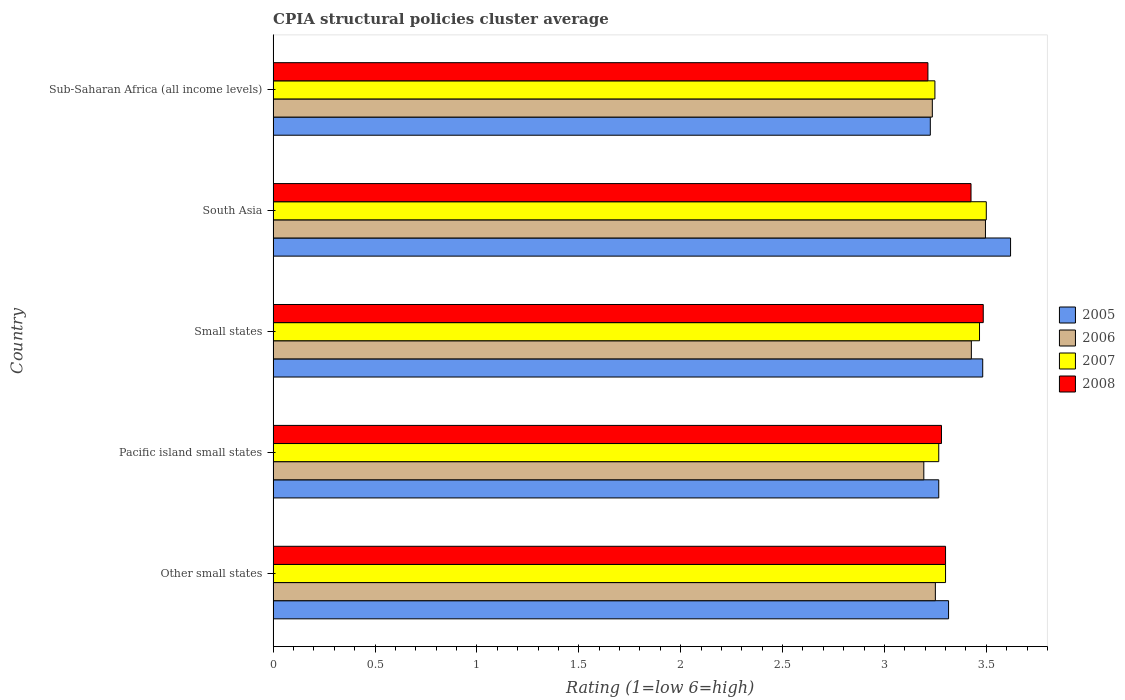Are the number of bars per tick equal to the number of legend labels?
Offer a very short reply. Yes. How many bars are there on the 5th tick from the bottom?
Your response must be concise. 4. What is the label of the 3rd group of bars from the top?
Provide a short and direct response. Small states. What is the CPIA rating in 2008 in Pacific island small states?
Offer a very short reply. 3.28. Across all countries, what is the maximum CPIA rating in 2008?
Provide a succinct answer. 3.48. Across all countries, what is the minimum CPIA rating in 2007?
Your answer should be very brief. 3.25. In which country was the CPIA rating in 2008 maximum?
Your answer should be compact. Small states. In which country was the CPIA rating in 2006 minimum?
Keep it short and to the point. Pacific island small states. What is the total CPIA rating in 2006 in the graph?
Provide a short and direct response. 16.6. What is the difference between the CPIA rating in 2005 in Other small states and that in Pacific island small states?
Make the answer very short. 0.05. What is the difference between the CPIA rating in 2007 in Pacific island small states and the CPIA rating in 2006 in Other small states?
Your answer should be very brief. 0.02. What is the average CPIA rating in 2008 per country?
Your answer should be compact. 3.34. What is the difference between the CPIA rating in 2007 and CPIA rating in 2006 in Sub-Saharan Africa (all income levels)?
Your answer should be compact. 0.01. In how many countries, is the CPIA rating in 2007 greater than 1.5 ?
Provide a short and direct response. 5. What is the ratio of the CPIA rating in 2005 in Pacific island small states to that in Sub-Saharan Africa (all income levels)?
Ensure brevity in your answer.  1.01. Is the difference between the CPIA rating in 2007 in Small states and South Asia greater than the difference between the CPIA rating in 2006 in Small states and South Asia?
Your response must be concise. Yes. What is the difference between the highest and the second highest CPIA rating in 2006?
Provide a succinct answer. 0.07. What is the difference between the highest and the lowest CPIA rating in 2006?
Provide a succinct answer. 0.3. In how many countries, is the CPIA rating in 2005 greater than the average CPIA rating in 2005 taken over all countries?
Provide a short and direct response. 2. Is the sum of the CPIA rating in 2008 in Other small states and Small states greater than the maximum CPIA rating in 2007 across all countries?
Provide a short and direct response. Yes. Is it the case that in every country, the sum of the CPIA rating in 2008 and CPIA rating in 2007 is greater than the CPIA rating in 2006?
Offer a terse response. Yes. How many countries are there in the graph?
Keep it short and to the point. 5. What is the difference between two consecutive major ticks on the X-axis?
Keep it short and to the point. 0.5. Does the graph contain grids?
Your response must be concise. No. How are the legend labels stacked?
Offer a terse response. Vertical. What is the title of the graph?
Your answer should be compact. CPIA structural policies cluster average. What is the label or title of the Y-axis?
Your answer should be very brief. Country. What is the Rating (1=low 6=high) of 2005 in Other small states?
Your response must be concise. 3.31. What is the Rating (1=low 6=high) in 2006 in Other small states?
Offer a very short reply. 3.25. What is the Rating (1=low 6=high) in 2008 in Other small states?
Keep it short and to the point. 3.3. What is the Rating (1=low 6=high) of 2005 in Pacific island small states?
Your response must be concise. 3.27. What is the Rating (1=low 6=high) of 2006 in Pacific island small states?
Make the answer very short. 3.19. What is the Rating (1=low 6=high) of 2007 in Pacific island small states?
Make the answer very short. 3.27. What is the Rating (1=low 6=high) in 2008 in Pacific island small states?
Keep it short and to the point. 3.28. What is the Rating (1=low 6=high) of 2005 in Small states?
Provide a succinct answer. 3.48. What is the Rating (1=low 6=high) of 2006 in Small states?
Your answer should be very brief. 3.43. What is the Rating (1=low 6=high) of 2007 in Small states?
Provide a succinct answer. 3.47. What is the Rating (1=low 6=high) of 2008 in Small states?
Your answer should be compact. 3.48. What is the Rating (1=low 6=high) of 2005 in South Asia?
Provide a short and direct response. 3.62. What is the Rating (1=low 6=high) in 2006 in South Asia?
Your response must be concise. 3.5. What is the Rating (1=low 6=high) of 2008 in South Asia?
Make the answer very short. 3.42. What is the Rating (1=low 6=high) in 2005 in Sub-Saharan Africa (all income levels)?
Your answer should be very brief. 3.23. What is the Rating (1=low 6=high) of 2006 in Sub-Saharan Africa (all income levels)?
Make the answer very short. 3.24. What is the Rating (1=low 6=high) in 2007 in Sub-Saharan Africa (all income levels)?
Your response must be concise. 3.25. What is the Rating (1=low 6=high) of 2008 in Sub-Saharan Africa (all income levels)?
Offer a terse response. 3.21. Across all countries, what is the maximum Rating (1=low 6=high) of 2005?
Your answer should be very brief. 3.62. Across all countries, what is the maximum Rating (1=low 6=high) in 2006?
Provide a succinct answer. 3.5. Across all countries, what is the maximum Rating (1=low 6=high) in 2008?
Give a very brief answer. 3.48. Across all countries, what is the minimum Rating (1=low 6=high) in 2005?
Provide a succinct answer. 3.23. Across all countries, what is the minimum Rating (1=low 6=high) in 2006?
Keep it short and to the point. 3.19. Across all countries, what is the minimum Rating (1=low 6=high) in 2007?
Provide a short and direct response. 3.25. Across all countries, what is the minimum Rating (1=low 6=high) in 2008?
Make the answer very short. 3.21. What is the total Rating (1=low 6=high) in 2005 in the graph?
Provide a short and direct response. 16.91. What is the total Rating (1=low 6=high) of 2006 in the graph?
Provide a succinct answer. 16.6. What is the total Rating (1=low 6=high) of 2007 in the graph?
Provide a succinct answer. 16.78. What is the total Rating (1=low 6=high) in 2008 in the graph?
Your response must be concise. 16.7. What is the difference between the Rating (1=low 6=high) in 2005 in Other small states and that in Pacific island small states?
Provide a short and direct response. 0.05. What is the difference between the Rating (1=low 6=high) in 2006 in Other small states and that in Pacific island small states?
Provide a short and direct response. 0.06. What is the difference between the Rating (1=low 6=high) in 2008 in Other small states and that in Pacific island small states?
Offer a terse response. 0.02. What is the difference between the Rating (1=low 6=high) of 2005 in Other small states and that in Small states?
Provide a short and direct response. -0.17. What is the difference between the Rating (1=low 6=high) in 2006 in Other small states and that in Small states?
Offer a very short reply. -0.18. What is the difference between the Rating (1=low 6=high) of 2008 in Other small states and that in Small states?
Provide a succinct answer. -0.18. What is the difference between the Rating (1=low 6=high) of 2005 in Other small states and that in South Asia?
Your answer should be very brief. -0.3. What is the difference between the Rating (1=low 6=high) in 2006 in Other small states and that in South Asia?
Your response must be concise. -0.25. What is the difference between the Rating (1=low 6=high) in 2008 in Other small states and that in South Asia?
Ensure brevity in your answer.  -0.12. What is the difference between the Rating (1=low 6=high) of 2005 in Other small states and that in Sub-Saharan Africa (all income levels)?
Your answer should be very brief. 0.09. What is the difference between the Rating (1=low 6=high) in 2006 in Other small states and that in Sub-Saharan Africa (all income levels)?
Provide a short and direct response. 0.01. What is the difference between the Rating (1=low 6=high) in 2007 in Other small states and that in Sub-Saharan Africa (all income levels)?
Your answer should be compact. 0.05. What is the difference between the Rating (1=low 6=high) in 2008 in Other small states and that in Sub-Saharan Africa (all income levels)?
Your answer should be very brief. 0.09. What is the difference between the Rating (1=low 6=high) in 2005 in Pacific island small states and that in Small states?
Offer a terse response. -0.22. What is the difference between the Rating (1=low 6=high) in 2006 in Pacific island small states and that in Small states?
Make the answer very short. -0.23. What is the difference between the Rating (1=low 6=high) of 2008 in Pacific island small states and that in Small states?
Your response must be concise. -0.2. What is the difference between the Rating (1=low 6=high) of 2005 in Pacific island small states and that in South Asia?
Make the answer very short. -0.35. What is the difference between the Rating (1=low 6=high) of 2006 in Pacific island small states and that in South Asia?
Offer a very short reply. -0.3. What is the difference between the Rating (1=low 6=high) of 2007 in Pacific island small states and that in South Asia?
Give a very brief answer. -0.23. What is the difference between the Rating (1=low 6=high) of 2008 in Pacific island small states and that in South Asia?
Your answer should be compact. -0.14. What is the difference between the Rating (1=low 6=high) of 2005 in Pacific island small states and that in Sub-Saharan Africa (all income levels)?
Offer a terse response. 0.04. What is the difference between the Rating (1=low 6=high) of 2006 in Pacific island small states and that in Sub-Saharan Africa (all income levels)?
Offer a very short reply. -0.04. What is the difference between the Rating (1=low 6=high) of 2007 in Pacific island small states and that in Sub-Saharan Africa (all income levels)?
Provide a succinct answer. 0.02. What is the difference between the Rating (1=low 6=high) in 2008 in Pacific island small states and that in Sub-Saharan Africa (all income levels)?
Provide a succinct answer. 0.07. What is the difference between the Rating (1=low 6=high) in 2005 in Small states and that in South Asia?
Make the answer very short. -0.14. What is the difference between the Rating (1=low 6=high) in 2006 in Small states and that in South Asia?
Give a very brief answer. -0.07. What is the difference between the Rating (1=low 6=high) of 2007 in Small states and that in South Asia?
Your answer should be very brief. -0.03. What is the difference between the Rating (1=low 6=high) of 2005 in Small states and that in Sub-Saharan Africa (all income levels)?
Your response must be concise. 0.26. What is the difference between the Rating (1=low 6=high) in 2006 in Small states and that in Sub-Saharan Africa (all income levels)?
Keep it short and to the point. 0.19. What is the difference between the Rating (1=low 6=high) in 2007 in Small states and that in Sub-Saharan Africa (all income levels)?
Your response must be concise. 0.22. What is the difference between the Rating (1=low 6=high) of 2008 in Small states and that in Sub-Saharan Africa (all income levels)?
Your answer should be very brief. 0.27. What is the difference between the Rating (1=low 6=high) of 2005 in South Asia and that in Sub-Saharan Africa (all income levels)?
Offer a very short reply. 0.39. What is the difference between the Rating (1=low 6=high) in 2006 in South Asia and that in Sub-Saharan Africa (all income levels)?
Offer a terse response. 0.26. What is the difference between the Rating (1=low 6=high) of 2007 in South Asia and that in Sub-Saharan Africa (all income levels)?
Your response must be concise. 0.25. What is the difference between the Rating (1=low 6=high) of 2008 in South Asia and that in Sub-Saharan Africa (all income levels)?
Offer a terse response. 0.21. What is the difference between the Rating (1=low 6=high) of 2005 in Other small states and the Rating (1=low 6=high) of 2006 in Pacific island small states?
Keep it short and to the point. 0.12. What is the difference between the Rating (1=low 6=high) of 2005 in Other small states and the Rating (1=low 6=high) of 2007 in Pacific island small states?
Give a very brief answer. 0.05. What is the difference between the Rating (1=low 6=high) in 2005 in Other small states and the Rating (1=low 6=high) in 2008 in Pacific island small states?
Ensure brevity in your answer.  0.03. What is the difference between the Rating (1=low 6=high) in 2006 in Other small states and the Rating (1=low 6=high) in 2007 in Pacific island small states?
Give a very brief answer. -0.02. What is the difference between the Rating (1=low 6=high) in 2006 in Other small states and the Rating (1=low 6=high) in 2008 in Pacific island small states?
Your response must be concise. -0.03. What is the difference between the Rating (1=low 6=high) of 2007 in Other small states and the Rating (1=low 6=high) of 2008 in Pacific island small states?
Make the answer very short. 0.02. What is the difference between the Rating (1=low 6=high) in 2005 in Other small states and the Rating (1=low 6=high) in 2006 in Small states?
Your response must be concise. -0.11. What is the difference between the Rating (1=low 6=high) of 2005 in Other small states and the Rating (1=low 6=high) of 2007 in Small states?
Offer a terse response. -0.15. What is the difference between the Rating (1=low 6=high) of 2005 in Other small states and the Rating (1=low 6=high) of 2008 in Small states?
Your answer should be very brief. -0.17. What is the difference between the Rating (1=low 6=high) of 2006 in Other small states and the Rating (1=low 6=high) of 2007 in Small states?
Your answer should be very brief. -0.22. What is the difference between the Rating (1=low 6=high) of 2006 in Other small states and the Rating (1=low 6=high) of 2008 in Small states?
Your answer should be very brief. -0.23. What is the difference between the Rating (1=low 6=high) in 2007 in Other small states and the Rating (1=low 6=high) in 2008 in Small states?
Make the answer very short. -0.18. What is the difference between the Rating (1=low 6=high) of 2005 in Other small states and the Rating (1=low 6=high) of 2006 in South Asia?
Offer a terse response. -0.18. What is the difference between the Rating (1=low 6=high) of 2005 in Other small states and the Rating (1=low 6=high) of 2007 in South Asia?
Provide a succinct answer. -0.19. What is the difference between the Rating (1=low 6=high) in 2005 in Other small states and the Rating (1=low 6=high) in 2008 in South Asia?
Ensure brevity in your answer.  -0.11. What is the difference between the Rating (1=low 6=high) of 2006 in Other small states and the Rating (1=low 6=high) of 2007 in South Asia?
Provide a short and direct response. -0.25. What is the difference between the Rating (1=low 6=high) of 2006 in Other small states and the Rating (1=low 6=high) of 2008 in South Asia?
Make the answer very short. -0.17. What is the difference between the Rating (1=low 6=high) in 2007 in Other small states and the Rating (1=low 6=high) in 2008 in South Asia?
Make the answer very short. -0.12. What is the difference between the Rating (1=low 6=high) in 2005 in Other small states and the Rating (1=low 6=high) in 2006 in Sub-Saharan Africa (all income levels)?
Offer a terse response. 0.08. What is the difference between the Rating (1=low 6=high) of 2005 in Other small states and the Rating (1=low 6=high) of 2007 in Sub-Saharan Africa (all income levels)?
Make the answer very short. 0.07. What is the difference between the Rating (1=low 6=high) of 2005 in Other small states and the Rating (1=low 6=high) of 2008 in Sub-Saharan Africa (all income levels)?
Your answer should be compact. 0.1. What is the difference between the Rating (1=low 6=high) in 2006 in Other small states and the Rating (1=low 6=high) in 2007 in Sub-Saharan Africa (all income levels)?
Keep it short and to the point. 0. What is the difference between the Rating (1=low 6=high) in 2006 in Other small states and the Rating (1=low 6=high) in 2008 in Sub-Saharan Africa (all income levels)?
Your response must be concise. 0.04. What is the difference between the Rating (1=low 6=high) of 2007 in Other small states and the Rating (1=low 6=high) of 2008 in Sub-Saharan Africa (all income levels)?
Your answer should be very brief. 0.09. What is the difference between the Rating (1=low 6=high) of 2005 in Pacific island small states and the Rating (1=low 6=high) of 2006 in Small states?
Your answer should be very brief. -0.16. What is the difference between the Rating (1=low 6=high) of 2005 in Pacific island small states and the Rating (1=low 6=high) of 2007 in Small states?
Keep it short and to the point. -0.2. What is the difference between the Rating (1=low 6=high) of 2005 in Pacific island small states and the Rating (1=low 6=high) of 2008 in Small states?
Your answer should be compact. -0.22. What is the difference between the Rating (1=low 6=high) in 2006 in Pacific island small states and the Rating (1=low 6=high) in 2007 in Small states?
Provide a succinct answer. -0.27. What is the difference between the Rating (1=low 6=high) of 2006 in Pacific island small states and the Rating (1=low 6=high) of 2008 in Small states?
Keep it short and to the point. -0.29. What is the difference between the Rating (1=low 6=high) in 2007 in Pacific island small states and the Rating (1=low 6=high) in 2008 in Small states?
Make the answer very short. -0.22. What is the difference between the Rating (1=low 6=high) of 2005 in Pacific island small states and the Rating (1=low 6=high) of 2006 in South Asia?
Your answer should be compact. -0.23. What is the difference between the Rating (1=low 6=high) in 2005 in Pacific island small states and the Rating (1=low 6=high) in 2007 in South Asia?
Your answer should be very brief. -0.23. What is the difference between the Rating (1=low 6=high) of 2005 in Pacific island small states and the Rating (1=low 6=high) of 2008 in South Asia?
Your answer should be very brief. -0.16. What is the difference between the Rating (1=low 6=high) of 2006 in Pacific island small states and the Rating (1=low 6=high) of 2007 in South Asia?
Your response must be concise. -0.31. What is the difference between the Rating (1=low 6=high) of 2006 in Pacific island small states and the Rating (1=low 6=high) of 2008 in South Asia?
Give a very brief answer. -0.23. What is the difference between the Rating (1=low 6=high) in 2007 in Pacific island small states and the Rating (1=low 6=high) in 2008 in South Asia?
Provide a succinct answer. -0.16. What is the difference between the Rating (1=low 6=high) in 2005 in Pacific island small states and the Rating (1=low 6=high) in 2006 in Sub-Saharan Africa (all income levels)?
Your answer should be compact. 0.03. What is the difference between the Rating (1=low 6=high) of 2005 in Pacific island small states and the Rating (1=low 6=high) of 2007 in Sub-Saharan Africa (all income levels)?
Your response must be concise. 0.02. What is the difference between the Rating (1=low 6=high) in 2005 in Pacific island small states and the Rating (1=low 6=high) in 2008 in Sub-Saharan Africa (all income levels)?
Provide a succinct answer. 0.05. What is the difference between the Rating (1=low 6=high) of 2006 in Pacific island small states and the Rating (1=low 6=high) of 2007 in Sub-Saharan Africa (all income levels)?
Make the answer very short. -0.05. What is the difference between the Rating (1=low 6=high) of 2006 in Pacific island small states and the Rating (1=low 6=high) of 2008 in Sub-Saharan Africa (all income levels)?
Make the answer very short. -0.02. What is the difference between the Rating (1=low 6=high) of 2007 in Pacific island small states and the Rating (1=low 6=high) of 2008 in Sub-Saharan Africa (all income levels)?
Your response must be concise. 0.05. What is the difference between the Rating (1=low 6=high) of 2005 in Small states and the Rating (1=low 6=high) of 2006 in South Asia?
Offer a very short reply. -0.01. What is the difference between the Rating (1=low 6=high) in 2005 in Small states and the Rating (1=low 6=high) in 2007 in South Asia?
Your answer should be compact. -0.02. What is the difference between the Rating (1=low 6=high) of 2005 in Small states and the Rating (1=low 6=high) of 2008 in South Asia?
Your answer should be very brief. 0.06. What is the difference between the Rating (1=low 6=high) in 2006 in Small states and the Rating (1=low 6=high) in 2007 in South Asia?
Your response must be concise. -0.07. What is the difference between the Rating (1=low 6=high) of 2006 in Small states and the Rating (1=low 6=high) of 2008 in South Asia?
Give a very brief answer. 0. What is the difference between the Rating (1=low 6=high) in 2007 in Small states and the Rating (1=low 6=high) in 2008 in South Asia?
Offer a very short reply. 0.04. What is the difference between the Rating (1=low 6=high) in 2005 in Small states and the Rating (1=low 6=high) in 2006 in Sub-Saharan Africa (all income levels)?
Make the answer very short. 0.25. What is the difference between the Rating (1=low 6=high) of 2005 in Small states and the Rating (1=low 6=high) of 2007 in Sub-Saharan Africa (all income levels)?
Ensure brevity in your answer.  0.23. What is the difference between the Rating (1=low 6=high) in 2005 in Small states and the Rating (1=low 6=high) in 2008 in Sub-Saharan Africa (all income levels)?
Offer a very short reply. 0.27. What is the difference between the Rating (1=low 6=high) in 2006 in Small states and the Rating (1=low 6=high) in 2007 in Sub-Saharan Africa (all income levels)?
Keep it short and to the point. 0.18. What is the difference between the Rating (1=low 6=high) of 2006 in Small states and the Rating (1=low 6=high) of 2008 in Sub-Saharan Africa (all income levels)?
Your answer should be very brief. 0.21. What is the difference between the Rating (1=low 6=high) in 2007 in Small states and the Rating (1=low 6=high) in 2008 in Sub-Saharan Africa (all income levels)?
Make the answer very short. 0.25. What is the difference between the Rating (1=low 6=high) of 2005 in South Asia and the Rating (1=low 6=high) of 2006 in Sub-Saharan Africa (all income levels)?
Keep it short and to the point. 0.38. What is the difference between the Rating (1=low 6=high) of 2005 in South Asia and the Rating (1=low 6=high) of 2007 in Sub-Saharan Africa (all income levels)?
Your answer should be compact. 0.37. What is the difference between the Rating (1=low 6=high) in 2005 in South Asia and the Rating (1=low 6=high) in 2008 in Sub-Saharan Africa (all income levels)?
Keep it short and to the point. 0.41. What is the difference between the Rating (1=low 6=high) in 2006 in South Asia and the Rating (1=low 6=high) in 2007 in Sub-Saharan Africa (all income levels)?
Your answer should be compact. 0.25. What is the difference between the Rating (1=low 6=high) in 2006 in South Asia and the Rating (1=low 6=high) in 2008 in Sub-Saharan Africa (all income levels)?
Give a very brief answer. 0.28. What is the difference between the Rating (1=low 6=high) of 2007 in South Asia and the Rating (1=low 6=high) of 2008 in Sub-Saharan Africa (all income levels)?
Keep it short and to the point. 0.29. What is the average Rating (1=low 6=high) in 2005 per country?
Provide a short and direct response. 3.38. What is the average Rating (1=low 6=high) in 2006 per country?
Offer a terse response. 3.32. What is the average Rating (1=low 6=high) of 2007 per country?
Provide a succinct answer. 3.36. What is the average Rating (1=low 6=high) of 2008 per country?
Offer a very short reply. 3.34. What is the difference between the Rating (1=low 6=high) in 2005 and Rating (1=low 6=high) in 2006 in Other small states?
Your answer should be very brief. 0.06. What is the difference between the Rating (1=low 6=high) of 2005 and Rating (1=low 6=high) of 2007 in Other small states?
Offer a very short reply. 0.01. What is the difference between the Rating (1=low 6=high) in 2005 and Rating (1=low 6=high) in 2008 in Other small states?
Your response must be concise. 0.01. What is the difference between the Rating (1=low 6=high) of 2005 and Rating (1=low 6=high) of 2006 in Pacific island small states?
Your response must be concise. 0.07. What is the difference between the Rating (1=low 6=high) in 2005 and Rating (1=low 6=high) in 2008 in Pacific island small states?
Offer a terse response. -0.01. What is the difference between the Rating (1=low 6=high) in 2006 and Rating (1=low 6=high) in 2007 in Pacific island small states?
Ensure brevity in your answer.  -0.07. What is the difference between the Rating (1=low 6=high) in 2006 and Rating (1=low 6=high) in 2008 in Pacific island small states?
Make the answer very short. -0.09. What is the difference between the Rating (1=low 6=high) of 2007 and Rating (1=low 6=high) of 2008 in Pacific island small states?
Provide a short and direct response. -0.01. What is the difference between the Rating (1=low 6=high) in 2005 and Rating (1=low 6=high) in 2006 in Small states?
Keep it short and to the point. 0.06. What is the difference between the Rating (1=low 6=high) in 2005 and Rating (1=low 6=high) in 2007 in Small states?
Offer a terse response. 0.02. What is the difference between the Rating (1=low 6=high) of 2005 and Rating (1=low 6=high) of 2008 in Small states?
Offer a terse response. -0. What is the difference between the Rating (1=low 6=high) of 2006 and Rating (1=low 6=high) of 2007 in Small states?
Offer a terse response. -0.04. What is the difference between the Rating (1=low 6=high) of 2006 and Rating (1=low 6=high) of 2008 in Small states?
Your answer should be compact. -0.06. What is the difference between the Rating (1=low 6=high) in 2007 and Rating (1=low 6=high) in 2008 in Small states?
Provide a short and direct response. -0.02. What is the difference between the Rating (1=low 6=high) of 2005 and Rating (1=low 6=high) of 2006 in South Asia?
Your answer should be very brief. 0.12. What is the difference between the Rating (1=low 6=high) of 2005 and Rating (1=low 6=high) of 2007 in South Asia?
Provide a succinct answer. 0.12. What is the difference between the Rating (1=low 6=high) of 2005 and Rating (1=low 6=high) of 2008 in South Asia?
Provide a succinct answer. 0.19. What is the difference between the Rating (1=low 6=high) in 2006 and Rating (1=low 6=high) in 2007 in South Asia?
Make the answer very short. -0. What is the difference between the Rating (1=low 6=high) in 2006 and Rating (1=low 6=high) in 2008 in South Asia?
Provide a short and direct response. 0.07. What is the difference between the Rating (1=low 6=high) in 2007 and Rating (1=low 6=high) in 2008 in South Asia?
Keep it short and to the point. 0.07. What is the difference between the Rating (1=low 6=high) in 2005 and Rating (1=low 6=high) in 2006 in Sub-Saharan Africa (all income levels)?
Keep it short and to the point. -0.01. What is the difference between the Rating (1=low 6=high) of 2005 and Rating (1=low 6=high) of 2007 in Sub-Saharan Africa (all income levels)?
Provide a short and direct response. -0.02. What is the difference between the Rating (1=low 6=high) in 2005 and Rating (1=low 6=high) in 2008 in Sub-Saharan Africa (all income levels)?
Provide a short and direct response. 0.01. What is the difference between the Rating (1=low 6=high) in 2006 and Rating (1=low 6=high) in 2007 in Sub-Saharan Africa (all income levels)?
Give a very brief answer. -0.01. What is the difference between the Rating (1=low 6=high) in 2006 and Rating (1=low 6=high) in 2008 in Sub-Saharan Africa (all income levels)?
Offer a very short reply. 0.02. What is the difference between the Rating (1=low 6=high) in 2007 and Rating (1=low 6=high) in 2008 in Sub-Saharan Africa (all income levels)?
Provide a short and direct response. 0.03. What is the ratio of the Rating (1=low 6=high) in 2005 in Other small states to that in Pacific island small states?
Offer a very short reply. 1.01. What is the ratio of the Rating (1=low 6=high) in 2006 in Other small states to that in Pacific island small states?
Your response must be concise. 1.02. What is the ratio of the Rating (1=low 6=high) of 2007 in Other small states to that in Pacific island small states?
Provide a succinct answer. 1.01. What is the ratio of the Rating (1=low 6=high) in 2008 in Other small states to that in Pacific island small states?
Offer a very short reply. 1.01. What is the ratio of the Rating (1=low 6=high) of 2005 in Other small states to that in Small states?
Offer a very short reply. 0.95. What is the ratio of the Rating (1=low 6=high) in 2006 in Other small states to that in Small states?
Provide a succinct answer. 0.95. What is the ratio of the Rating (1=low 6=high) of 2007 in Other small states to that in Small states?
Make the answer very short. 0.95. What is the ratio of the Rating (1=low 6=high) in 2008 in Other small states to that in Small states?
Provide a succinct answer. 0.95. What is the ratio of the Rating (1=low 6=high) of 2005 in Other small states to that in South Asia?
Offer a very short reply. 0.92. What is the ratio of the Rating (1=low 6=high) in 2006 in Other small states to that in South Asia?
Your answer should be very brief. 0.93. What is the ratio of the Rating (1=low 6=high) of 2007 in Other small states to that in South Asia?
Provide a short and direct response. 0.94. What is the ratio of the Rating (1=low 6=high) in 2008 in Other small states to that in South Asia?
Make the answer very short. 0.96. What is the ratio of the Rating (1=low 6=high) of 2005 in Other small states to that in Sub-Saharan Africa (all income levels)?
Provide a short and direct response. 1.03. What is the ratio of the Rating (1=low 6=high) of 2006 in Other small states to that in Sub-Saharan Africa (all income levels)?
Make the answer very short. 1. What is the ratio of the Rating (1=low 6=high) of 2007 in Other small states to that in Sub-Saharan Africa (all income levels)?
Give a very brief answer. 1.02. What is the ratio of the Rating (1=low 6=high) of 2008 in Other small states to that in Sub-Saharan Africa (all income levels)?
Keep it short and to the point. 1.03. What is the ratio of the Rating (1=low 6=high) in 2005 in Pacific island small states to that in Small states?
Keep it short and to the point. 0.94. What is the ratio of the Rating (1=low 6=high) in 2006 in Pacific island small states to that in Small states?
Give a very brief answer. 0.93. What is the ratio of the Rating (1=low 6=high) in 2007 in Pacific island small states to that in Small states?
Give a very brief answer. 0.94. What is the ratio of the Rating (1=low 6=high) of 2008 in Pacific island small states to that in Small states?
Provide a succinct answer. 0.94. What is the ratio of the Rating (1=low 6=high) of 2005 in Pacific island small states to that in South Asia?
Provide a short and direct response. 0.9. What is the ratio of the Rating (1=low 6=high) of 2006 in Pacific island small states to that in South Asia?
Provide a succinct answer. 0.91. What is the ratio of the Rating (1=low 6=high) of 2008 in Pacific island small states to that in South Asia?
Your response must be concise. 0.96. What is the ratio of the Rating (1=low 6=high) of 2005 in Pacific island small states to that in Sub-Saharan Africa (all income levels)?
Your answer should be compact. 1.01. What is the ratio of the Rating (1=low 6=high) of 2006 in Pacific island small states to that in Sub-Saharan Africa (all income levels)?
Give a very brief answer. 0.99. What is the ratio of the Rating (1=low 6=high) in 2008 in Pacific island small states to that in Sub-Saharan Africa (all income levels)?
Provide a succinct answer. 1.02. What is the ratio of the Rating (1=low 6=high) in 2005 in Small states to that in South Asia?
Keep it short and to the point. 0.96. What is the ratio of the Rating (1=low 6=high) in 2006 in Small states to that in South Asia?
Provide a short and direct response. 0.98. What is the ratio of the Rating (1=low 6=high) in 2007 in Small states to that in South Asia?
Offer a terse response. 0.99. What is the ratio of the Rating (1=low 6=high) of 2008 in Small states to that in South Asia?
Your response must be concise. 1.02. What is the ratio of the Rating (1=low 6=high) of 2005 in Small states to that in Sub-Saharan Africa (all income levels)?
Give a very brief answer. 1.08. What is the ratio of the Rating (1=low 6=high) in 2006 in Small states to that in Sub-Saharan Africa (all income levels)?
Offer a very short reply. 1.06. What is the ratio of the Rating (1=low 6=high) in 2007 in Small states to that in Sub-Saharan Africa (all income levels)?
Your answer should be very brief. 1.07. What is the ratio of the Rating (1=low 6=high) of 2008 in Small states to that in Sub-Saharan Africa (all income levels)?
Provide a succinct answer. 1.08. What is the ratio of the Rating (1=low 6=high) of 2005 in South Asia to that in Sub-Saharan Africa (all income levels)?
Offer a very short reply. 1.12. What is the ratio of the Rating (1=low 6=high) in 2006 in South Asia to that in Sub-Saharan Africa (all income levels)?
Make the answer very short. 1.08. What is the ratio of the Rating (1=low 6=high) in 2007 in South Asia to that in Sub-Saharan Africa (all income levels)?
Your answer should be compact. 1.08. What is the ratio of the Rating (1=low 6=high) in 2008 in South Asia to that in Sub-Saharan Africa (all income levels)?
Your answer should be compact. 1.07. What is the difference between the highest and the second highest Rating (1=low 6=high) of 2005?
Ensure brevity in your answer.  0.14. What is the difference between the highest and the second highest Rating (1=low 6=high) of 2006?
Provide a succinct answer. 0.07. What is the difference between the highest and the second highest Rating (1=low 6=high) of 2007?
Your answer should be compact. 0.03. What is the difference between the highest and the lowest Rating (1=low 6=high) of 2005?
Offer a terse response. 0.39. What is the difference between the highest and the lowest Rating (1=low 6=high) in 2006?
Your response must be concise. 0.3. What is the difference between the highest and the lowest Rating (1=low 6=high) of 2007?
Give a very brief answer. 0.25. What is the difference between the highest and the lowest Rating (1=low 6=high) of 2008?
Offer a terse response. 0.27. 